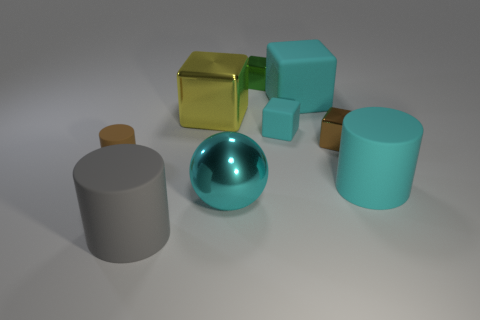What material is the small thing that is the same color as the big matte block?
Give a very brief answer. Rubber. There is a metallic object right of the big cyan object that is behind the small brown object that is left of the cyan metal thing; what shape is it?
Ensure brevity in your answer.  Cube. What shape is the brown object that is on the left side of the big rubber thing in front of the metallic ball?
Ensure brevity in your answer.  Cylinder. How many tiny matte blocks are there?
Give a very brief answer. 1. How many matte things are both in front of the small brown matte thing and on the left side of the metallic ball?
Provide a succinct answer. 1. Are there any other things that are the same shape as the cyan metallic thing?
Your response must be concise. No. Do the large shiny sphere and the large cylinder behind the gray rubber thing have the same color?
Make the answer very short. Yes. What is the shape of the large rubber object that is behind the cyan cylinder?
Offer a terse response. Cube. How many other things are made of the same material as the brown block?
Your answer should be compact. 3. What material is the big yellow object?
Your response must be concise. Metal. 